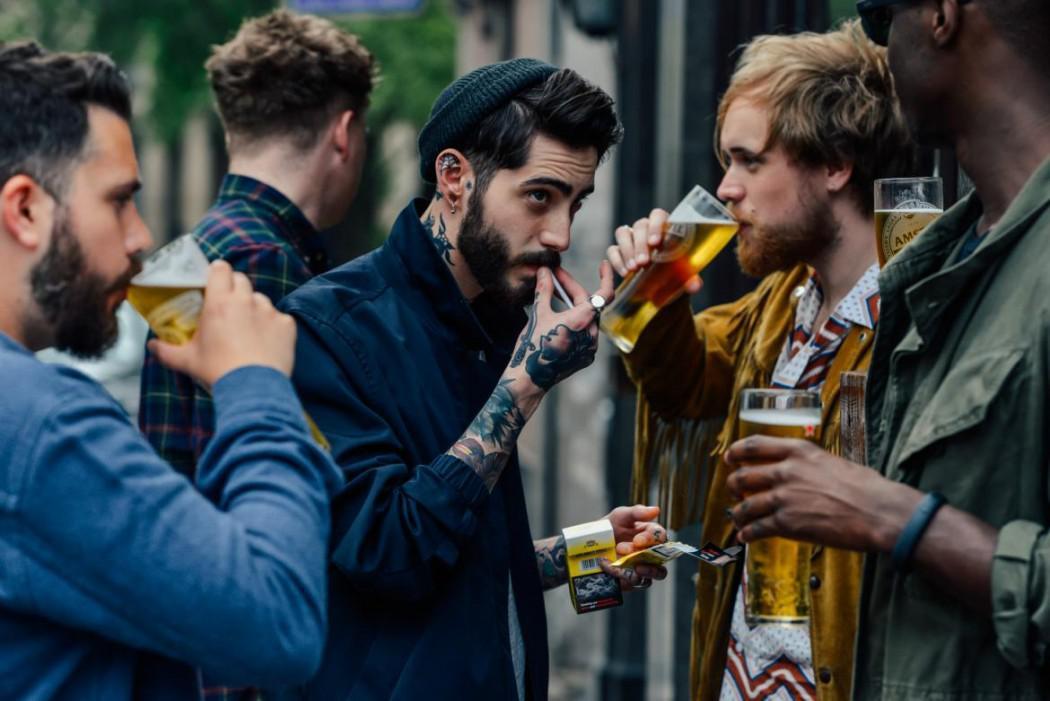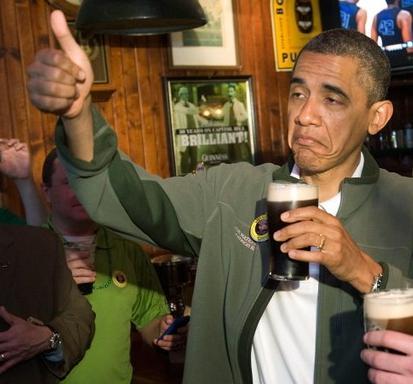The first image is the image on the left, the second image is the image on the right. Analyze the images presented: Is the assertion "A man is holding a bottle to his mouth." valid? Answer yes or no. No. 